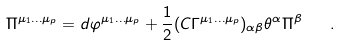Convert formula to latex. <formula><loc_0><loc_0><loc_500><loc_500>\Pi ^ { \mu _ { 1 } \dots \mu _ { p } } = d \varphi ^ { \mu _ { 1 } \dots \mu _ { p } } + { \frac { 1 } { 2 } } ( C \Gamma ^ { \mu _ { 1 } \dots \mu _ { p } } ) _ { \alpha \beta } \theta ^ { \alpha } \Pi ^ { \beta } \quad .</formula> 